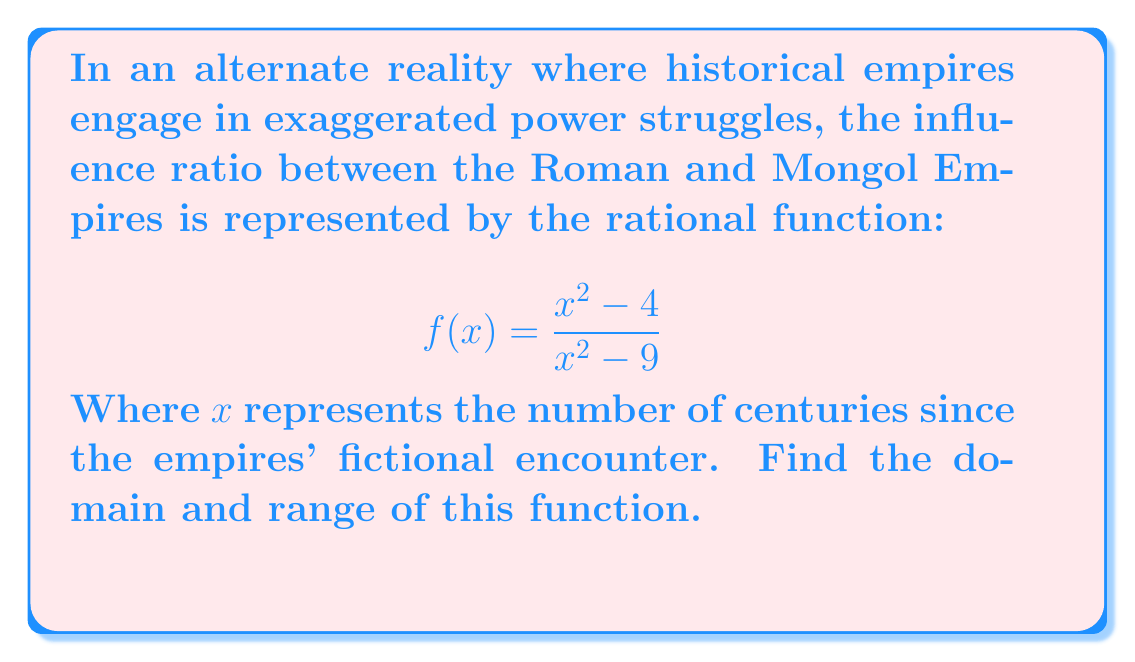Can you answer this question? To find the domain and range of $f(x) = \frac{x^2 - 4}{x^2 - 9}$, we follow these steps:

1. Domain:
   The domain includes all real numbers except those that make the denominator zero.
   Set the denominator to zero and solve:
   $x^2 - 9 = 0$
   $(x+3)(x-3) = 0$
   $x = \pm 3$
   Therefore, the domain is all real numbers except -3 and 3.

2. Range:
   a) Rewrite the function:
      $f(x) = \frac{x^2 - 4}{x^2 - 9} = \frac{(x+2)(x-2)}{(x+3)(x-3)}$

   b) Find the horizontal asymptote:
      As $x \to \infty$, $f(x) \to 1$

   c) Analyze behavior near vertical asymptotes:
      As $x \to 3^+$, $f(x) \to +\infty$
      As $x \to 3^-$, $f(x) \to -\infty$
      As $x \to -3^+$, $f(x) \to -\infty$
      As $x \to -3^-$, $f(x) \to +\infty$

   d) Find critical points:
      Set numerator equal to denominator:
      $x^2 - 4 = x^2 - 9$
      $5 = 0$ (impossible)
      Therefore, the graph never crosses y = 1.

   e) The function is continuous on $(-\infty, -3)$, $(-3, 3)$, and $(3, \infty)$.
      It approaches $-\infty$ and $+\infty$ near the vertical asymptotes.

Therefore, the range is all real numbers except 1.
Answer: Domain: $\{x \in \mathbb{R} : x \neq \pm 3\}$; Range: $\{y \in \mathbb{R} : y \neq 1\}$ 